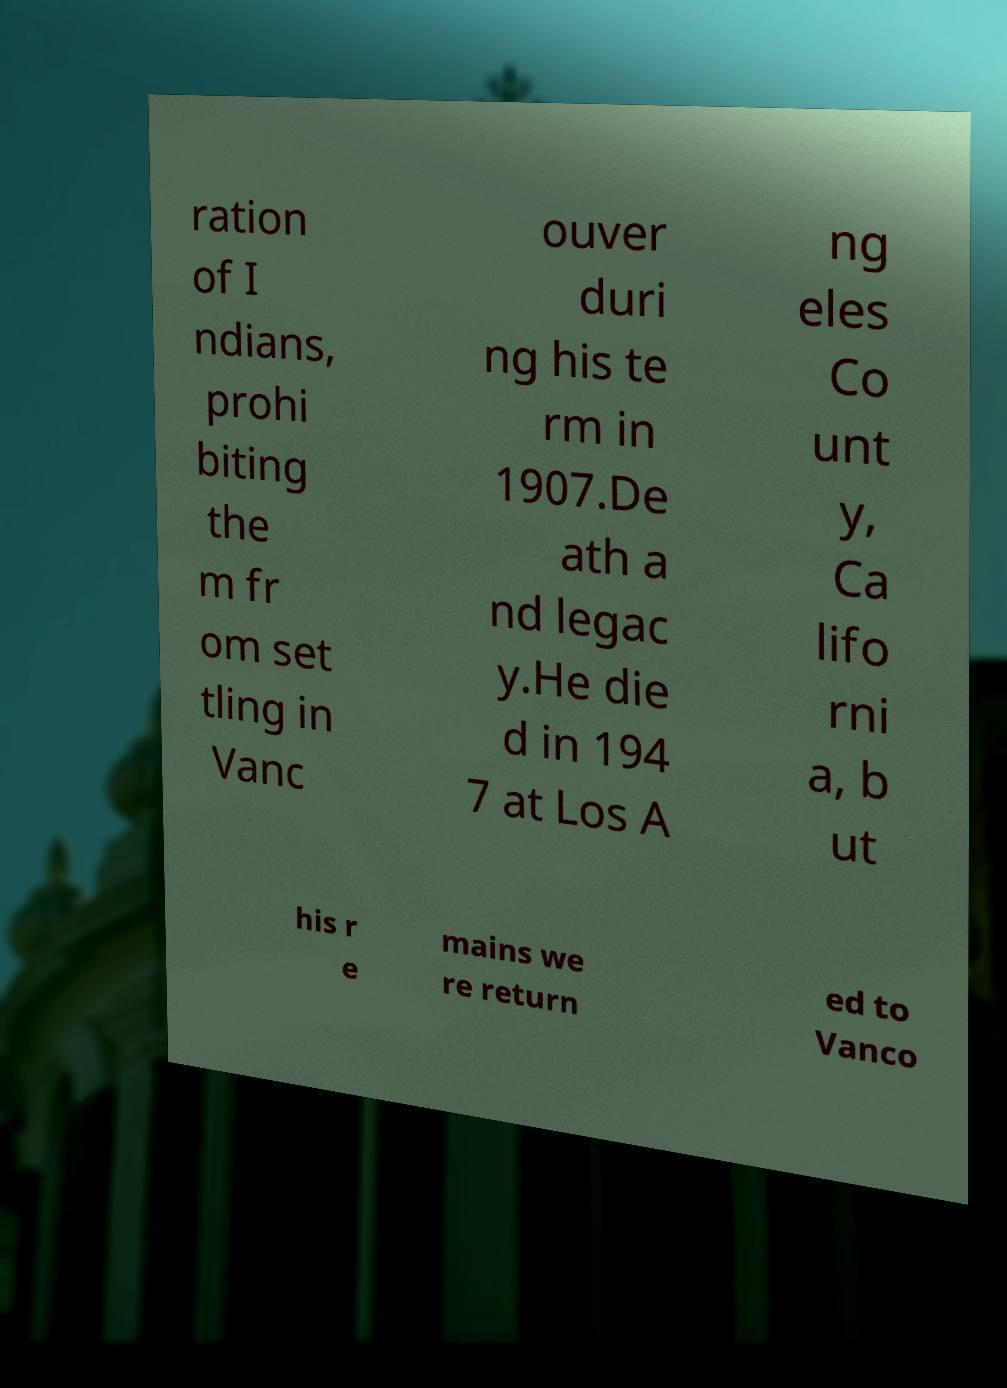Please read and relay the text visible in this image. What does it say? ration of I ndians, prohi biting the m fr om set tling in Vanc ouver duri ng his te rm in 1907.De ath a nd legac y.He die d in 194 7 at Los A ng eles Co unt y, Ca lifo rni a, b ut his r e mains we re return ed to Vanco 